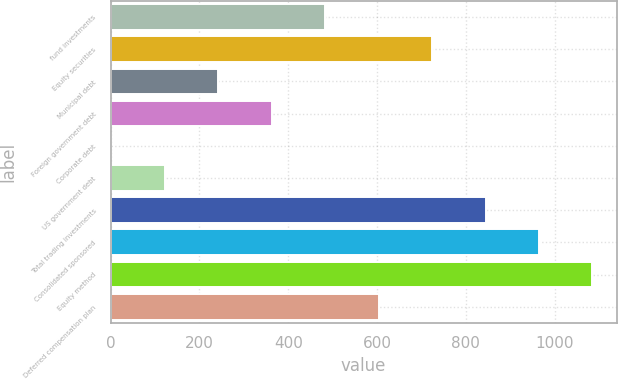Convert chart. <chart><loc_0><loc_0><loc_500><loc_500><bar_chart><fcel>fund investments<fcel>Equity securities<fcel>Municipal debt<fcel>Foreign government debt<fcel>Corporate debt<fcel>US government debt<fcel>Total trading investments<fcel>Consolidated sponsored<fcel>Equity method<fcel>Deferred compensation plan<nl><fcel>483<fcel>724<fcel>242<fcel>362.5<fcel>1<fcel>121.5<fcel>844.5<fcel>965<fcel>1085.5<fcel>603.5<nl></chart> 